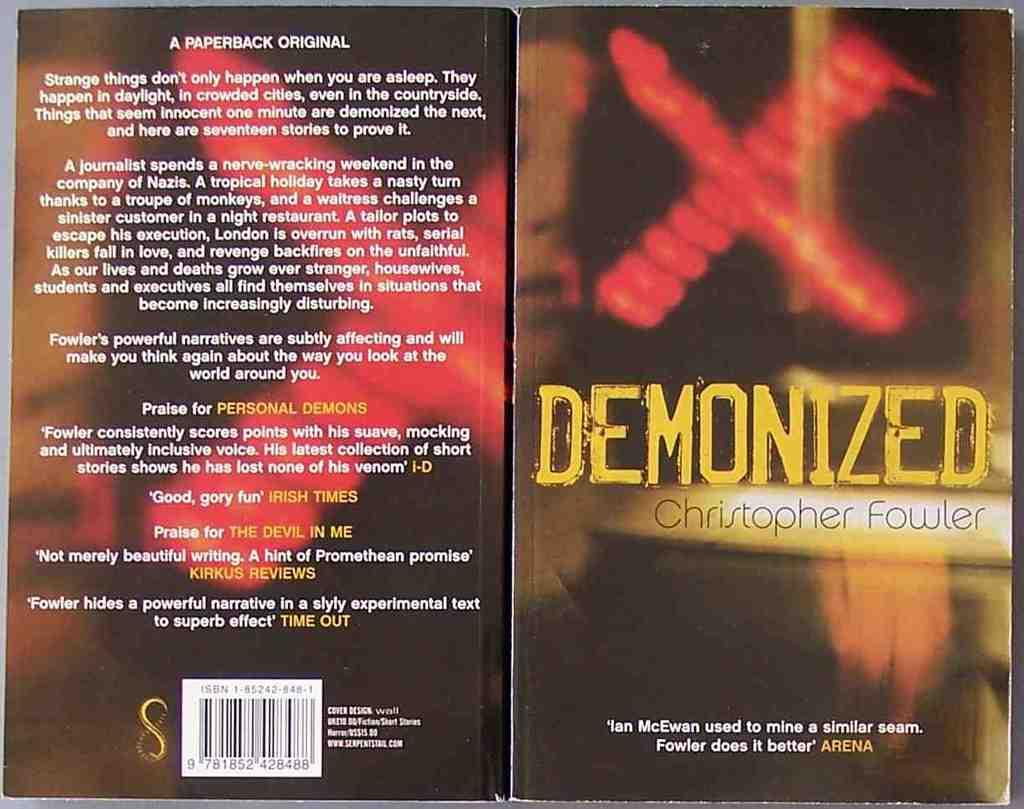Provide a one-sentence caption for the provided image. A book by Christopher Fowler with a red X cover design is titled Demonized. 